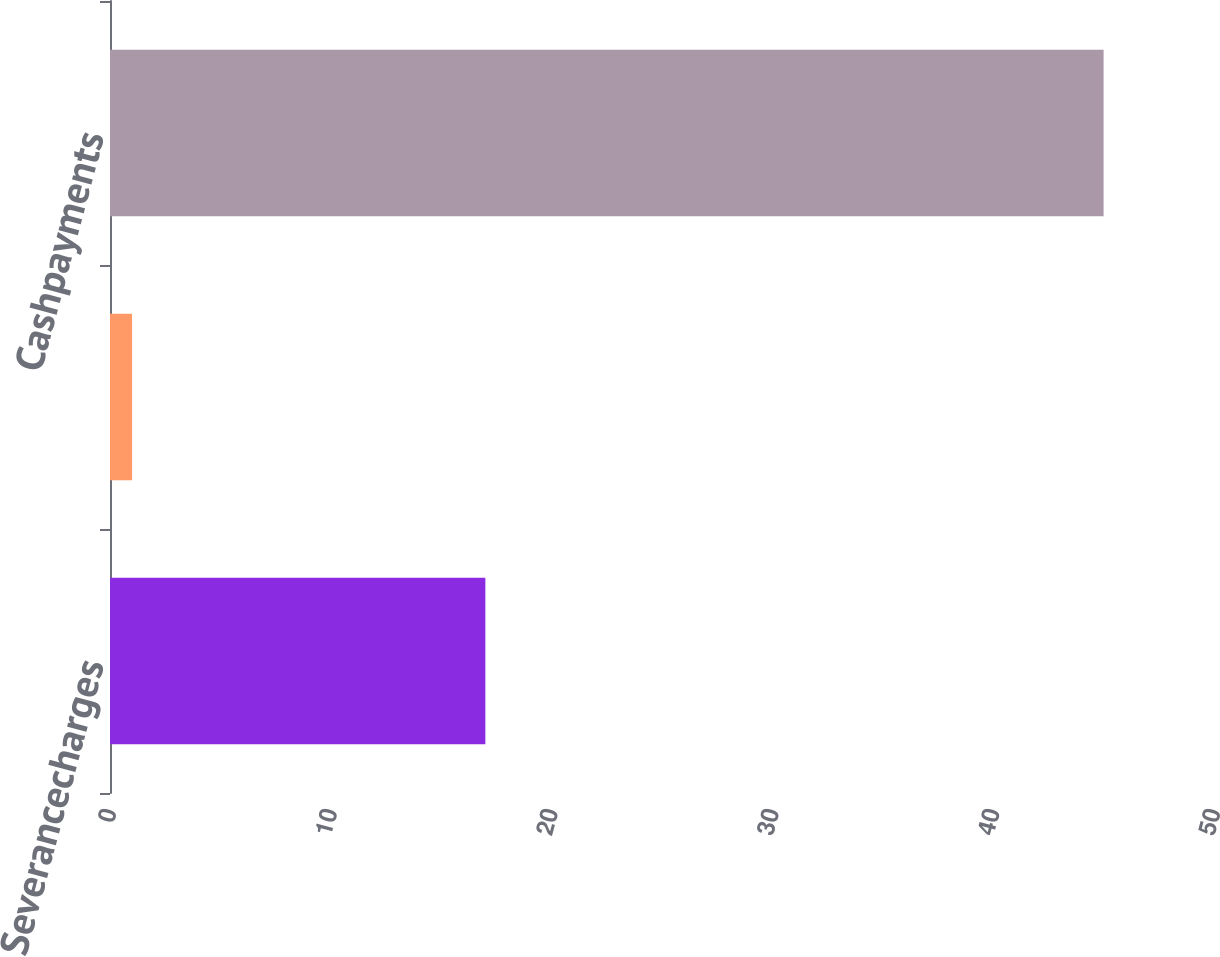Convert chart to OTSL. <chart><loc_0><loc_0><loc_500><loc_500><bar_chart><fcel>Severancecharges<fcel>Unnamed: 1<fcel>Cashpayments<nl><fcel>17<fcel>1<fcel>45<nl></chart> 